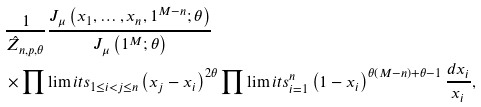Convert formula to latex. <formula><loc_0><loc_0><loc_500><loc_500>& \frac { 1 } { \hat { Z } _ { n , p , \theta } } \frac { J _ { \mu } \left ( x _ { 1 } , \dots , x _ { n } , 1 ^ { M - n } ; \theta \right ) } { J _ { \mu } \left ( 1 ^ { M } ; \theta \right ) } \\ & \times \prod \lim i t s _ { 1 \leq i < j \leq n } \left ( x _ { j } - x _ { i } \right ) ^ { 2 \theta } \prod \lim i t s _ { i = 1 } ^ { n } \left ( 1 - x _ { i } \right ) ^ { \theta \left ( M - n \right ) + \theta - 1 } \frac { d x _ { i } } { x _ { i } } ,</formula> 